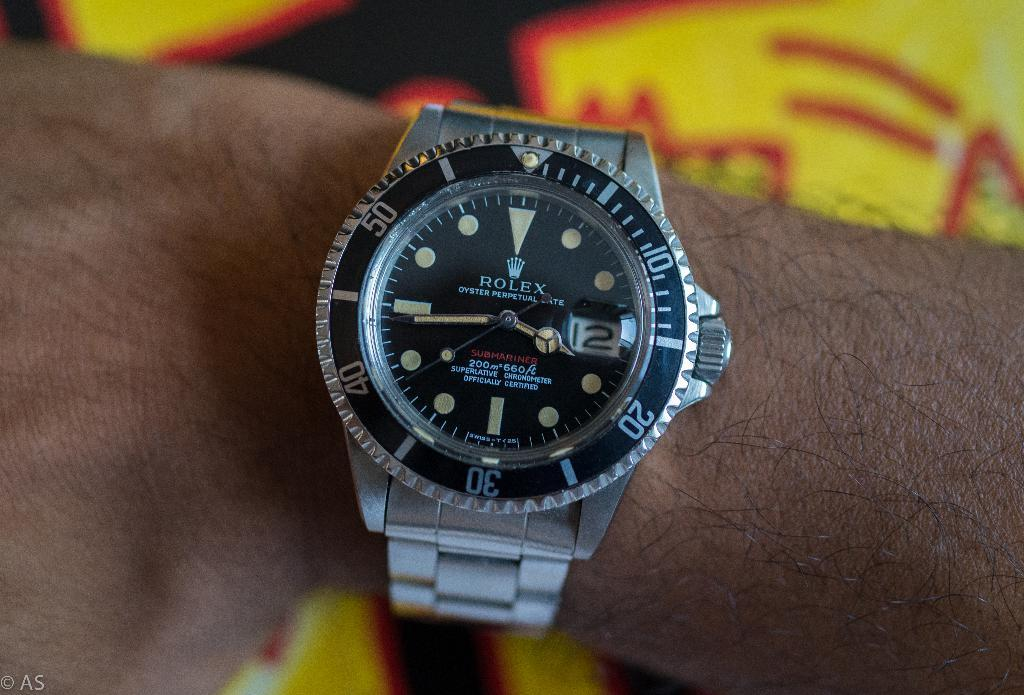<image>
Offer a succinct explanation of the picture presented. A silver and black Rolex watch on someone's hand. 